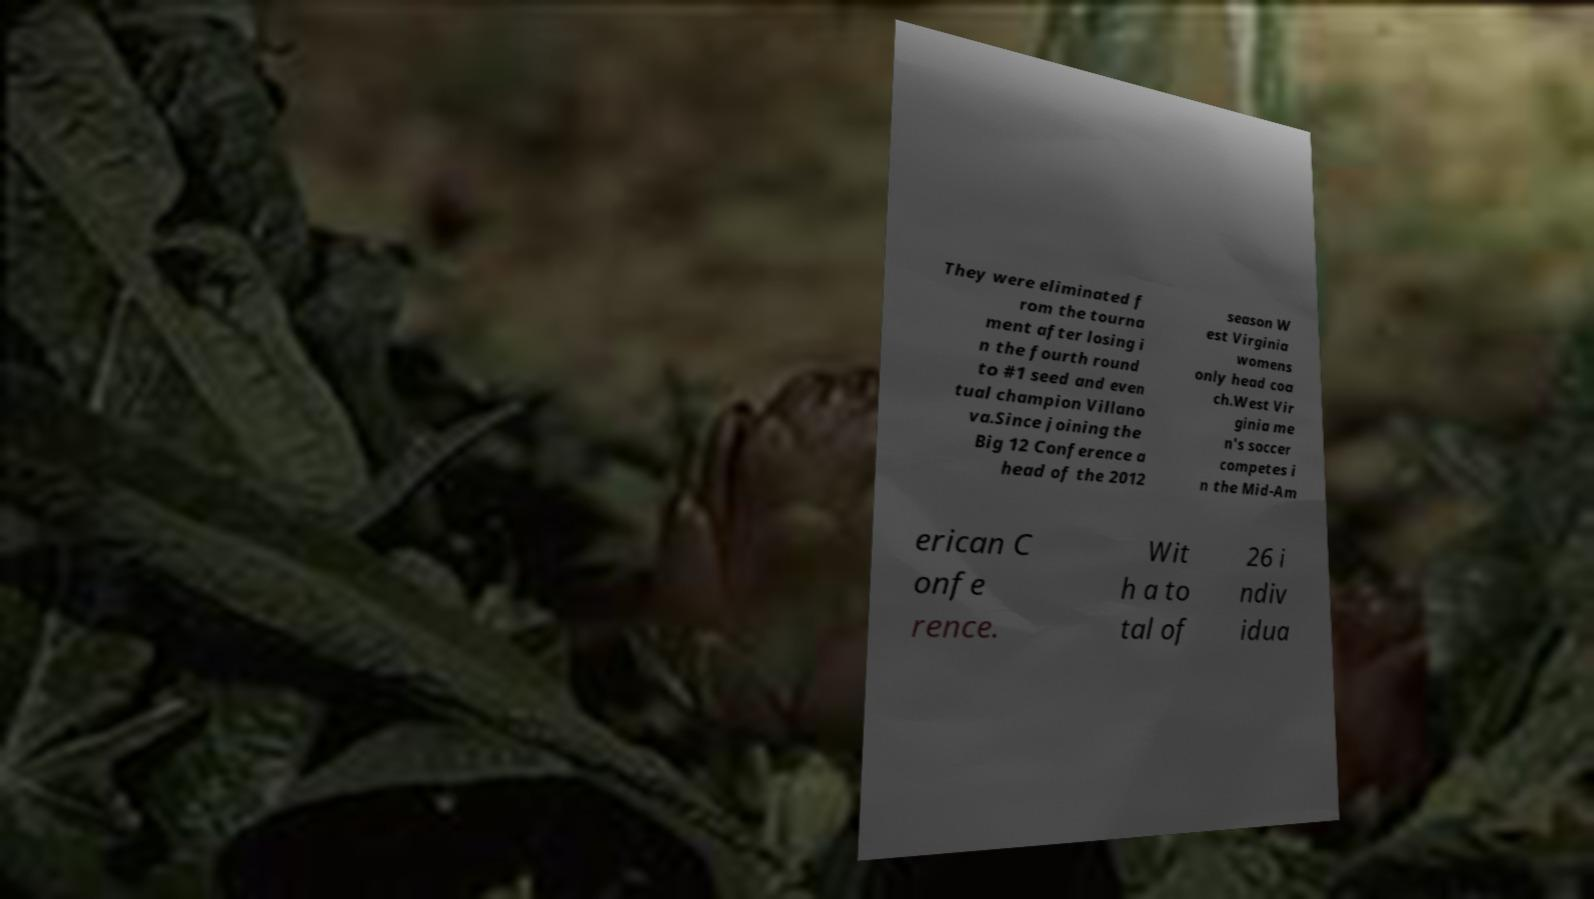Could you extract and type out the text from this image? They were eliminated f rom the tourna ment after losing i n the fourth round to #1 seed and even tual champion Villano va.Since joining the Big 12 Conference a head of the 2012 season W est Virginia womens only head coa ch.West Vir ginia me n's soccer competes i n the Mid-Am erican C onfe rence. Wit h a to tal of 26 i ndiv idua 